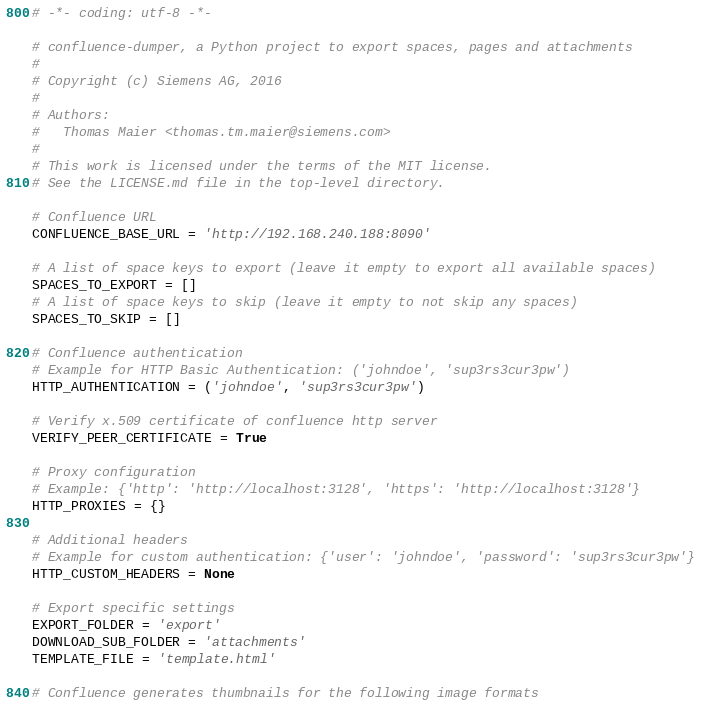<code> <loc_0><loc_0><loc_500><loc_500><_Python_># -*- coding: utf-8 -*-

# confluence-dumper, a Python project to export spaces, pages and attachments
#
# Copyright (c) Siemens AG, 2016
#
# Authors:
#   Thomas Maier <thomas.tm.maier@siemens.com>
#
# This work is licensed under the terms of the MIT license.
# See the LICENSE.md file in the top-level directory.

# Confluence URL
CONFLUENCE_BASE_URL = 'http://192.168.240.188:8090'

# A list of space keys to export (leave it empty to export all available spaces)
SPACES_TO_EXPORT = []
# A list of space keys to skip (leave it empty to not skip any spaces)
SPACES_TO_SKIP = []

# Confluence authentication
# Example for HTTP Basic Authentication: ('johndoe', 'sup3rs3cur3pw')
HTTP_AUTHENTICATION = ('johndoe', 'sup3rs3cur3pw')

# Verify x.509 certificate of confluence http server
VERIFY_PEER_CERTIFICATE = True

# Proxy configuration
# Example: {'http': 'http://localhost:3128', 'https': 'http://localhost:3128'}
HTTP_PROXIES = {}

# Additional headers
# Example for custom authentication: {'user': 'johndoe', 'password': 'sup3rs3cur3pw'}
HTTP_CUSTOM_HEADERS = None

# Export specific settings
EXPORT_FOLDER = 'export'
DOWNLOAD_SUB_FOLDER = 'attachments'
TEMPLATE_FILE = 'template.html'

# Confluence generates thumbnails for the following image formats</code> 